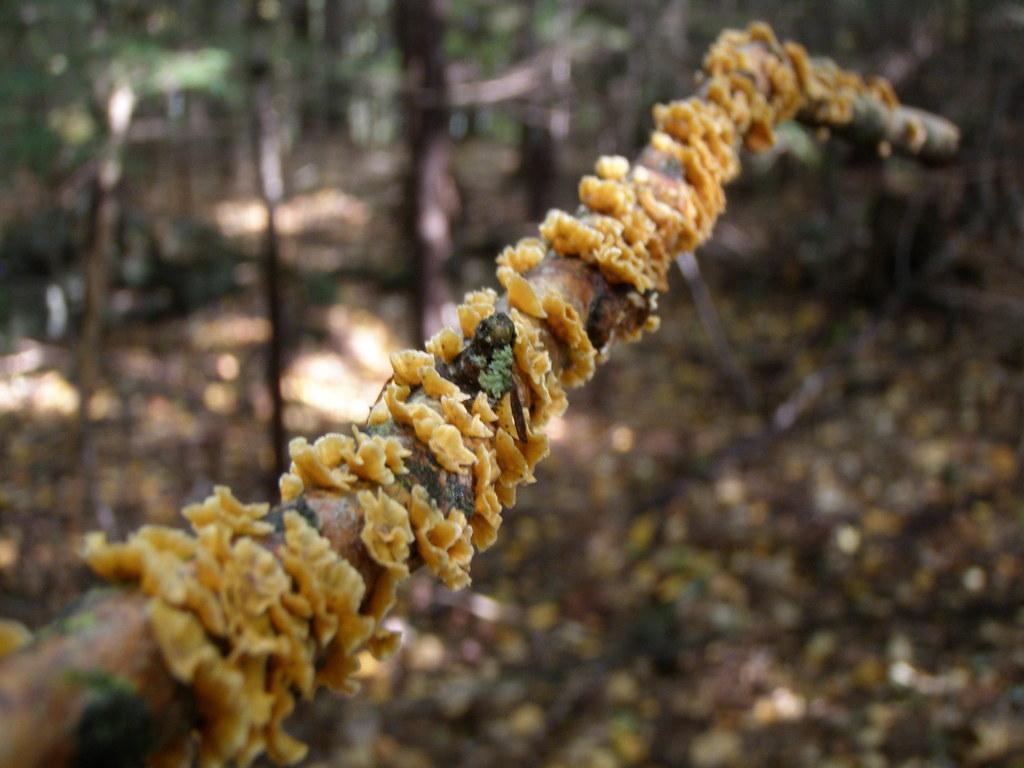Can you describe this image briefly? Here I can see a fungus on a stick. This place is looking like a forest. The background is blurred. 